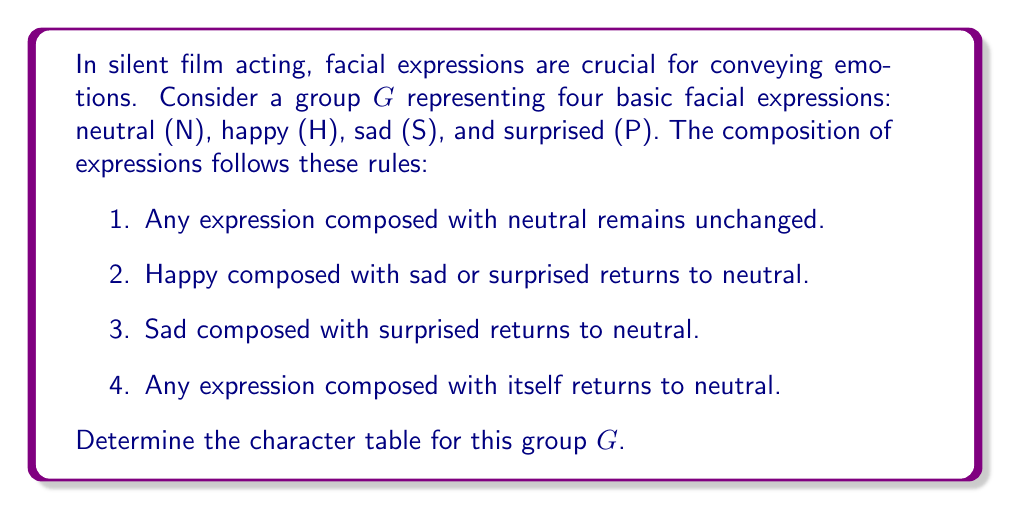Provide a solution to this math problem. Let's approach this step-by-step:

1) First, we need to identify the group elements and structure:
   $G = \{N, H, S, P\}$
   This is an abelian group of order 4.

2) The group operation table:
   $$\begin{array}{c|cccc}
     \circ & N & H & S & P \\
     \hline
     N & N & H & S & P \\
     H & H & N & N & N \\
     S & S & N & N & N \\
     P & P & N & N & N
   \end{array}$$

3) We can see that this group is isomorphic to Klein four-group $V_4$ or $C_2 \times C_2$.

4) For an abelian group, the number of irreducible representations equals the number of conjugacy classes, which equals the number of elements. So, we have 4 irreducible representations, all 1-dimensional.

5) The character table will have 4 rows (one for each irreducible representation) and 4 columns (one for each conjugacy class/element).

6) The first row is always the trivial representation, which maps every element to 1.

7) For the other representations, we need to ensure orthogonality. Given the group structure, we can deduce:
   - One representation where $H = -1, S = 1, P = 1$
   - One where $H = 1, S = -1, P = 1$
   - One where $H = 1, S = 1, P = -1$

8) Therefore, the character table is:
   $$\begin{array}{c|cccc}
     & N & H & S & P \\
     \hline
     \chi_1 & 1 & 1 & 1 & 1 \\
     \chi_2 & 1 & -1 & 1 & 1 \\
     \chi_3 & 1 & 1 & -1 & 1 \\
     \chi_4 & 1 & 1 & 1 & -1
   \end{array}$$

This character table satisfies all the properties required, including orthogonality of rows and columns.
Answer: $$\begin{array}{c|cccc}
 & N & H & S & P \\
\hline
\chi_1 & 1 & 1 & 1 & 1 \\
\chi_2 & 1 & -1 & 1 & 1 \\
\chi_3 & 1 & 1 & -1 & 1 \\
\chi_4 & 1 & 1 & 1 & -1
\end{array}$$ 